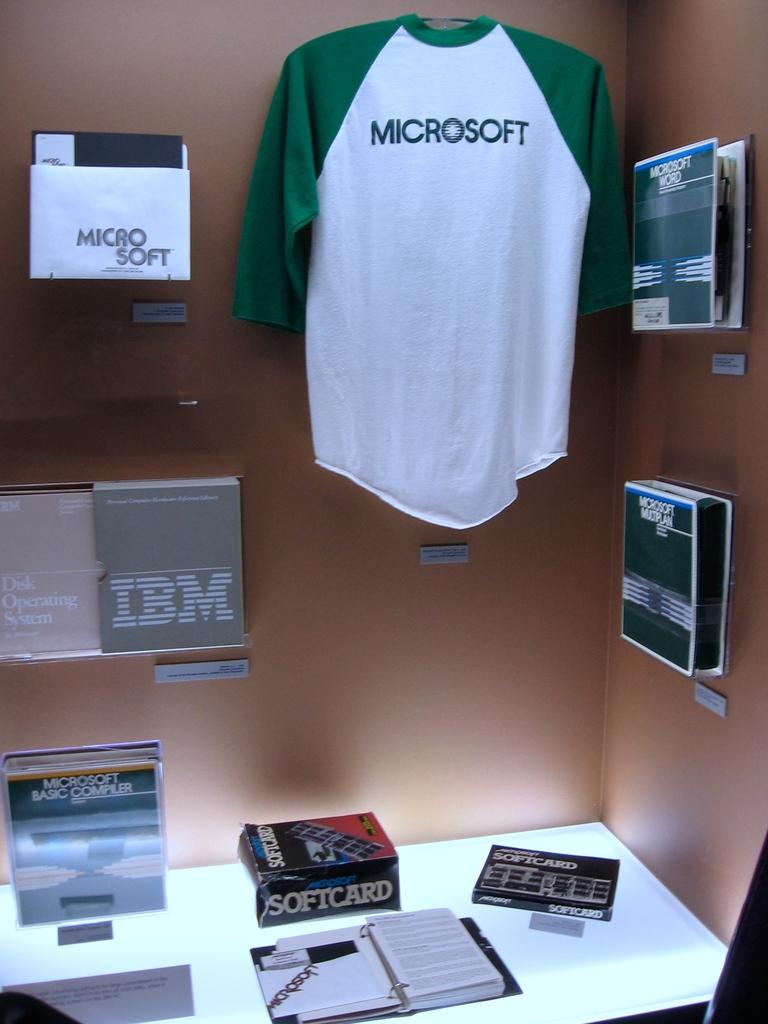<image>
Provide a brief description of the given image. Microsoft software and merchandise is displayed on the walls and the table. 